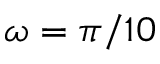<formula> <loc_0><loc_0><loc_500><loc_500>\omega = \pi / 1 0</formula> 